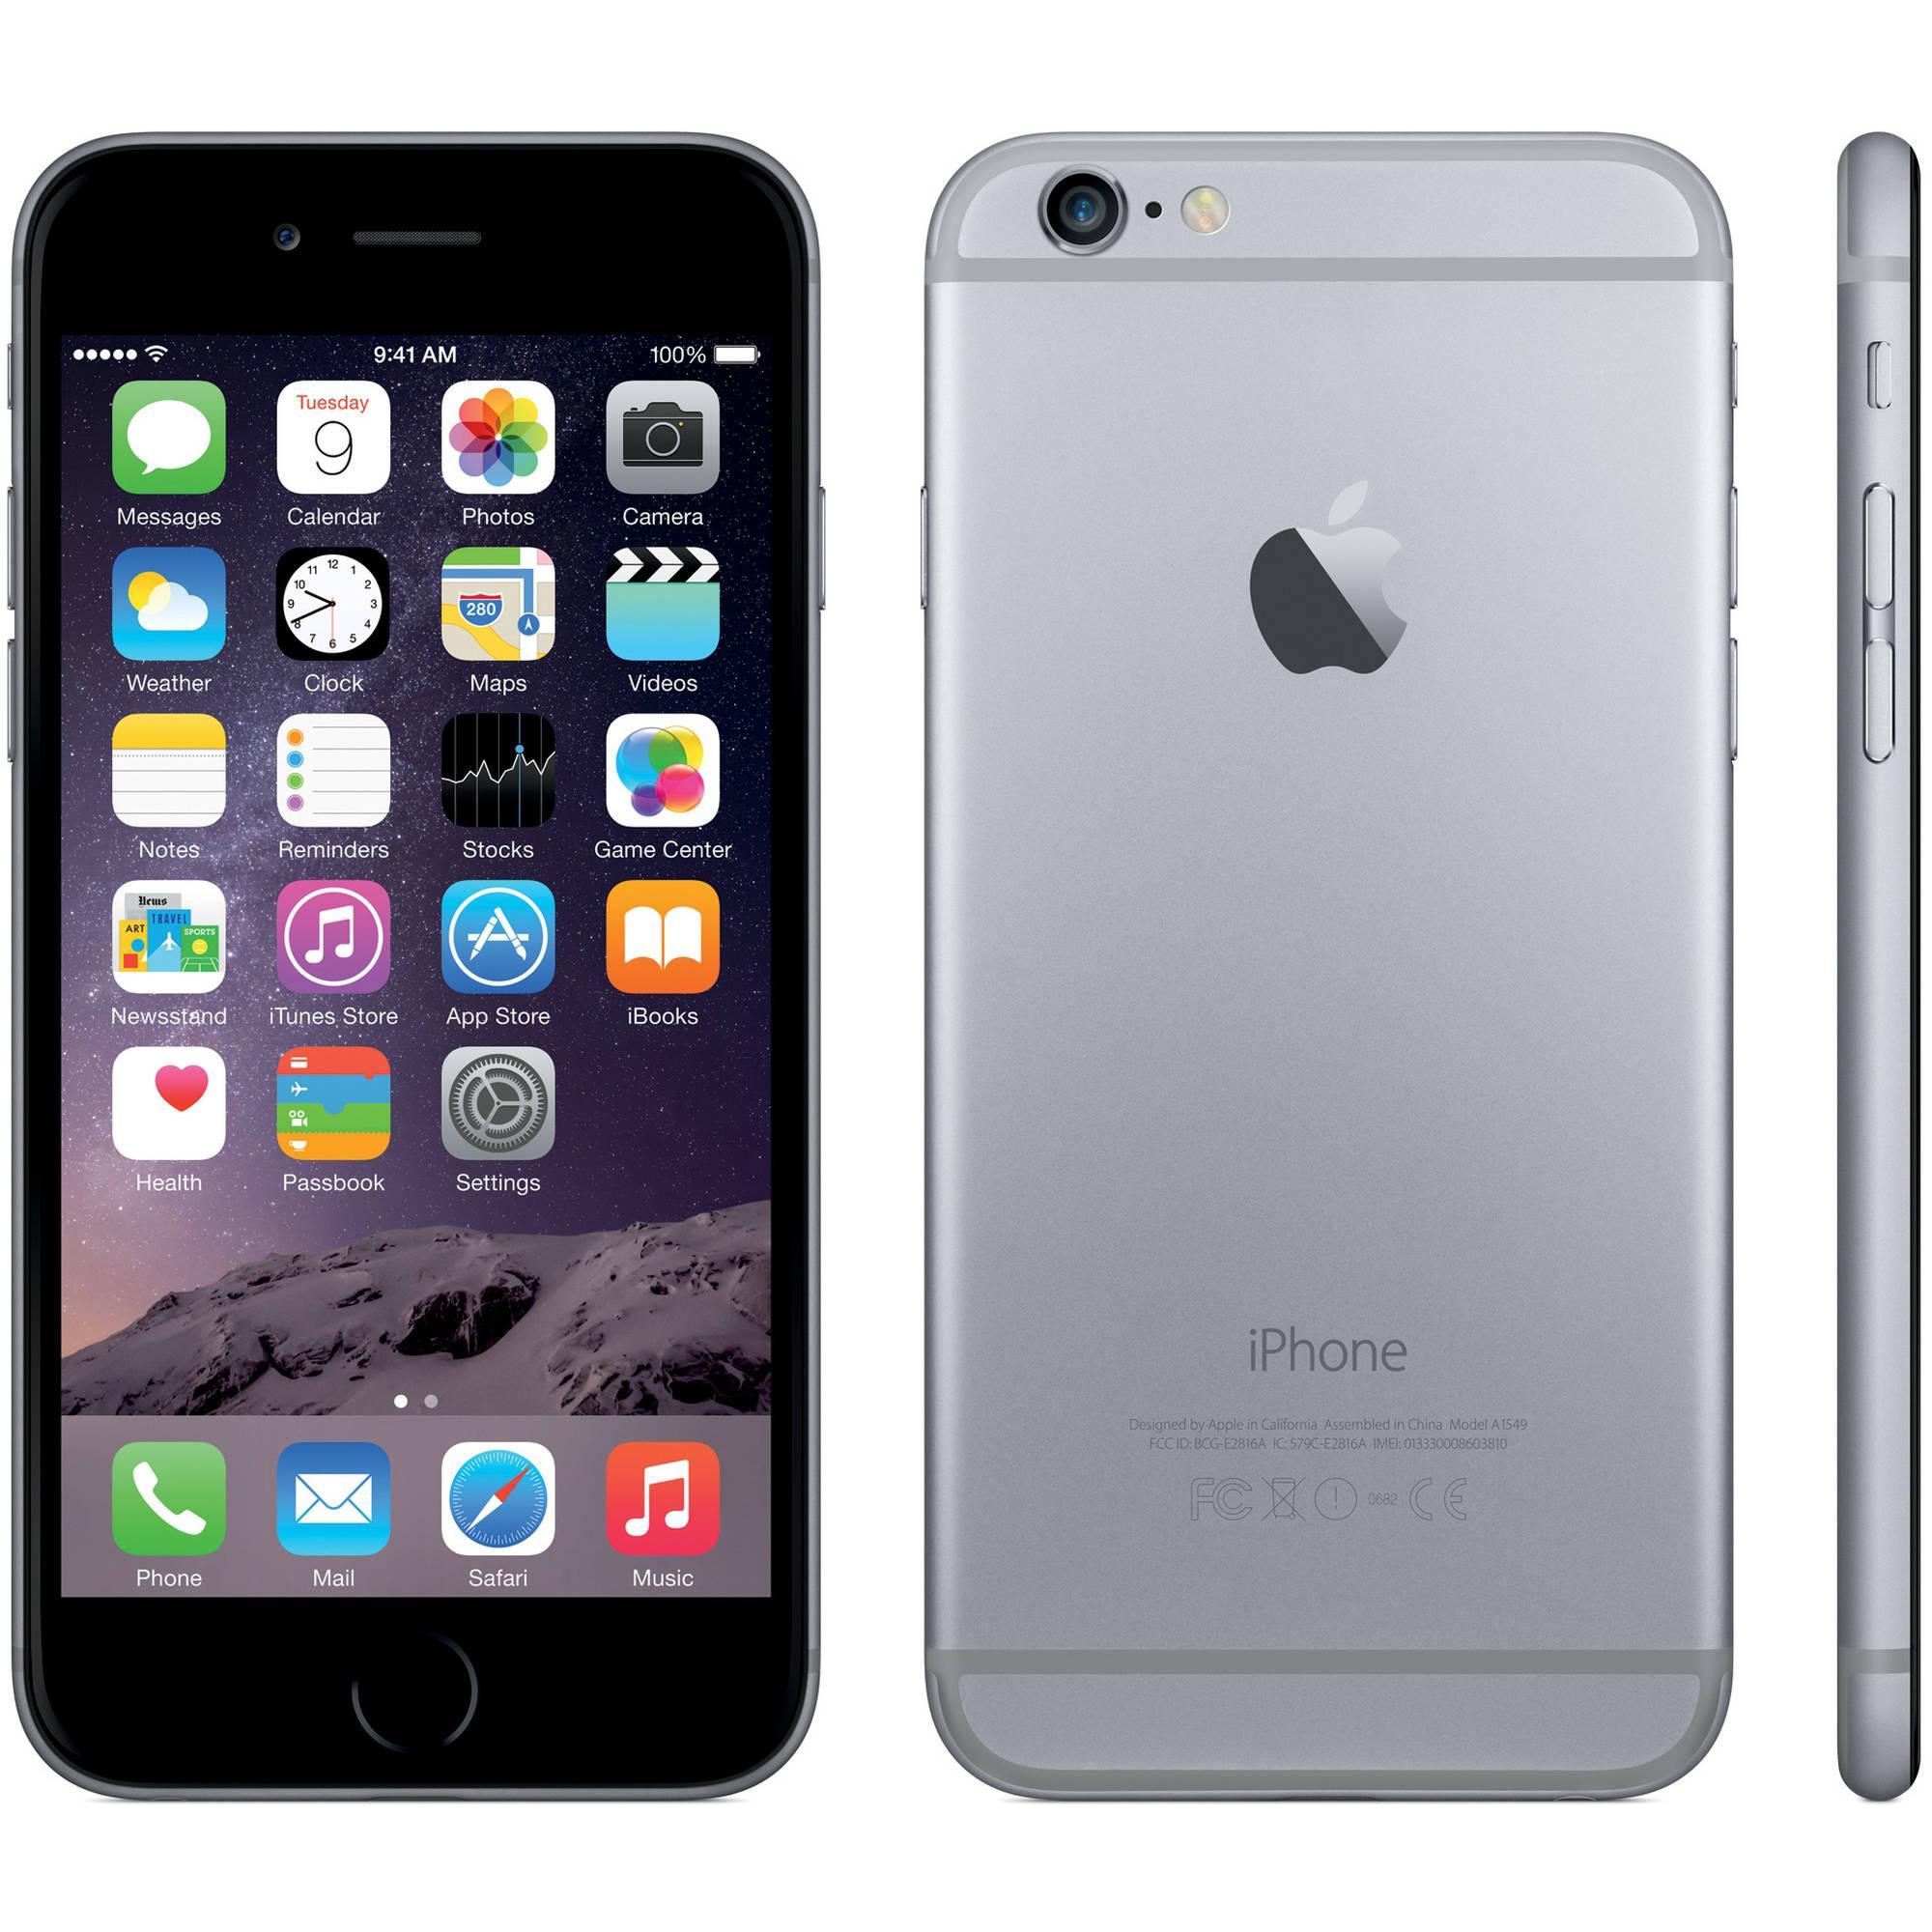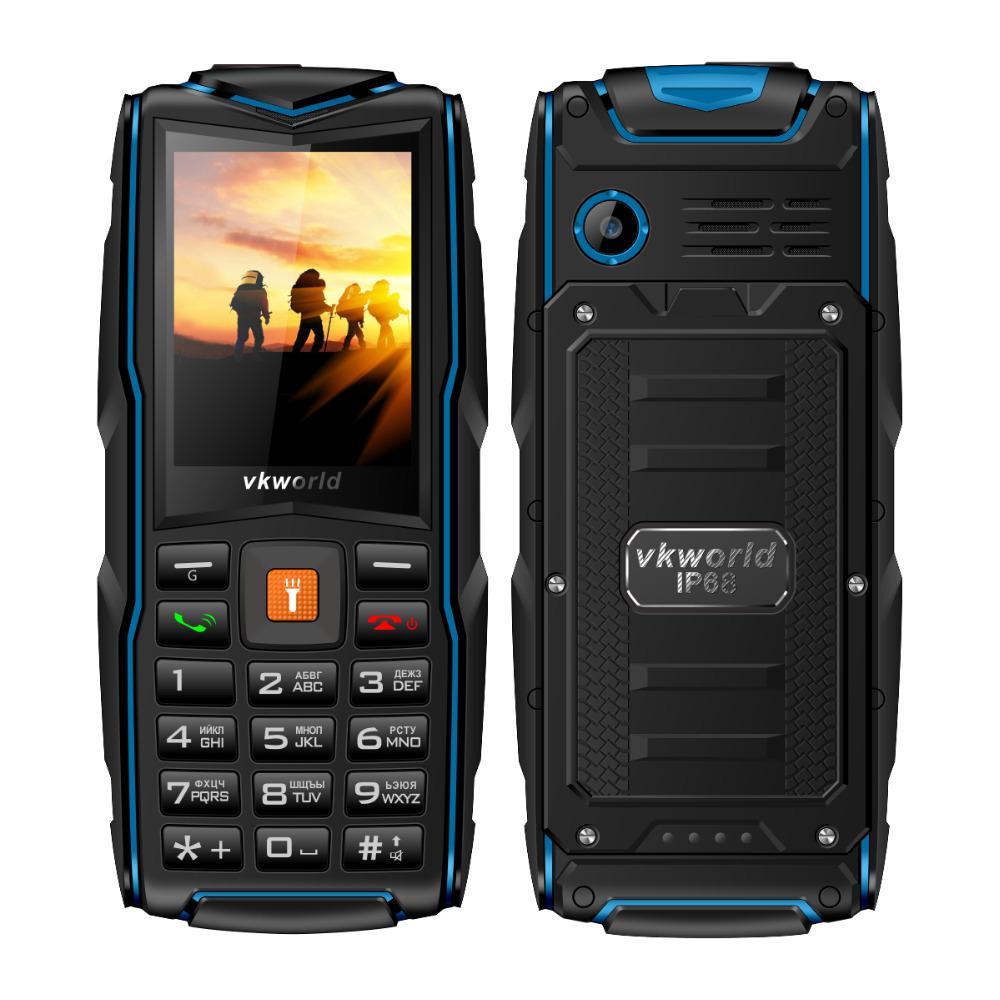The first image is the image on the left, the second image is the image on the right. For the images displayed, is the sentence "The back of a phone is completely visible." factually correct? Answer yes or no. Yes. The first image is the image on the left, the second image is the image on the right. Considering the images on both sides, is "There is  total of four phones with the right side having more." valid? Answer yes or no. No. 